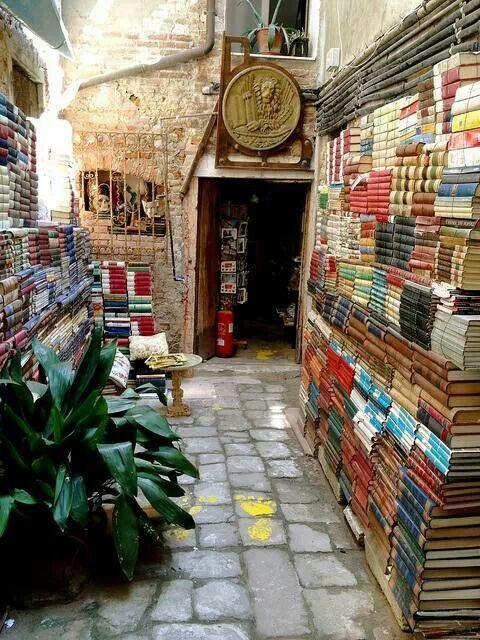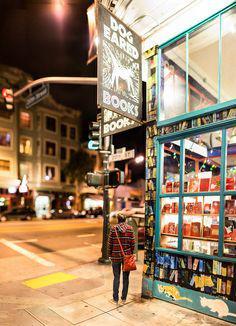The first image is the image on the left, the second image is the image on the right. Given the left and right images, does the statement "There is a bicycle hanging from the ceiling." hold true? Answer yes or no. No. The first image is the image on the left, the second image is the image on the right. Examine the images to the left and right. Is the description "One of the images includes a bicycle suspended in the air." accurate? Answer yes or no. No. 